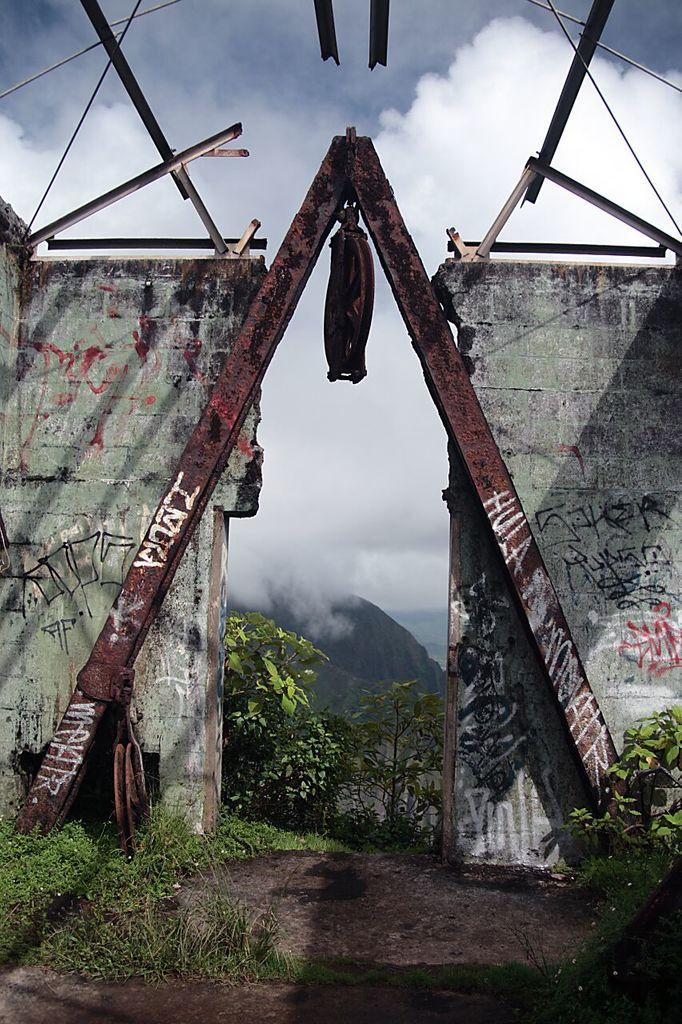What type of vegetation can be seen in the image? There are plants and grass in the image. What kind of surface is present for walking or traversing? There is a path in the image. What material are the objects in the image made of? There are metal objects in the image. What can be seen in the sky in the background of the image? There are clouds in the sky in the background. What type of geographical feature is visible in the distance? There are hills visible in the background. What type of net is being used in the image? There is no net present in the image. 